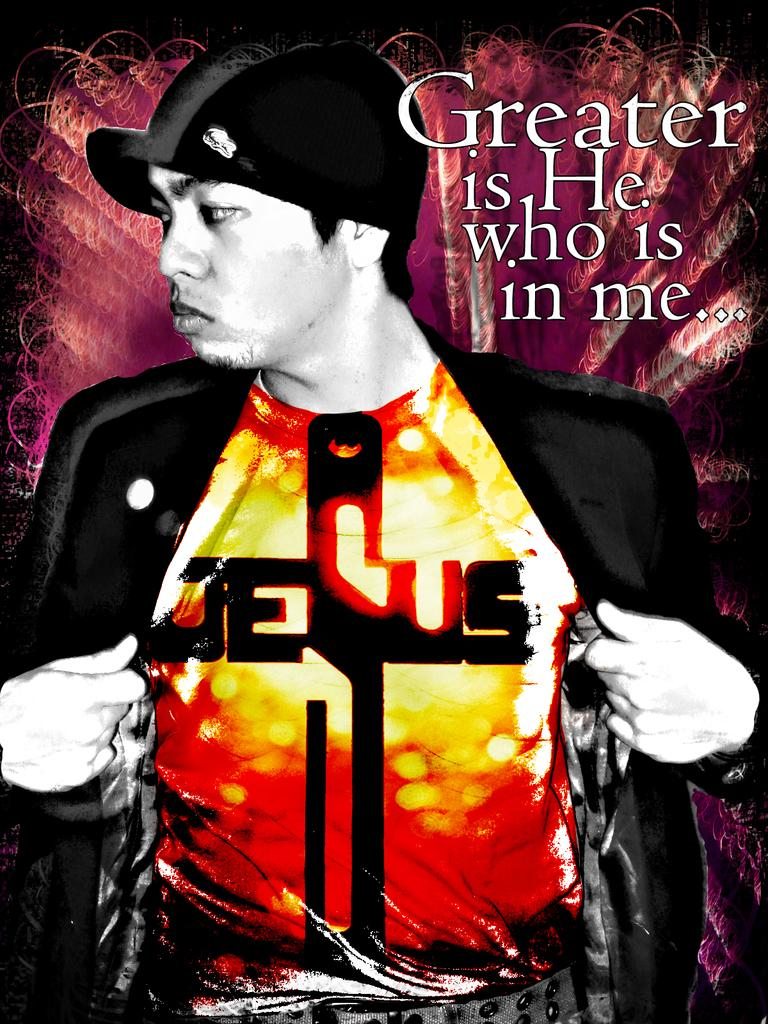Provide a one-sentence caption for the provided image. Man showing his shirt which says the word Jesus. 